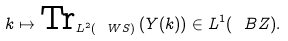Convert formula to latex. <formula><loc_0><loc_0><loc_500><loc_500>k \mapsto \text {Tr} _ { L ^ { 2 } ( \ W S ) } \left ( Y ( k ) \right ) \in L ^ { 1 } ( \ B Z ) .</formula> 